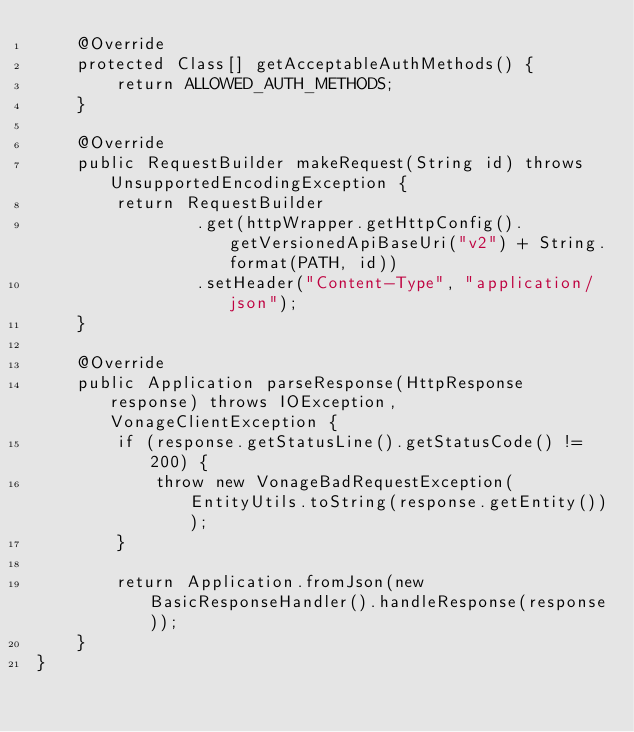Convert code to text. <code><loc_0><loc_0><loc_500><loc_500><_Java_>    @Override
    protected Class[] getAcceptableAuthMethods() {
        return ALLOWED_AUTH_METHODS;
    }

    @Override
    public RequestBuilder makeRequest(String id) throws UnsupportedEncodingException {
        return RequestBuilder
                .get(httpWrapper.getHttpConfig().getVersionedApiBaseUri("v2") + String.format(PATH, id))
                .setHeader("Content-Type", "application/json");
    }

    @Override
    public Application parseResponse(HttpResponse response) throws IOException, VonageClientException {
        if (response.getStatusLine().getStatusCode() != 200) {
            throw new VonageBadRequestException(EntityUtils.toString(response.getEntity()));
        }

        return Application.fromJson(new BasicResponseHandler().handleResponse(response));
    }
}
</code> 